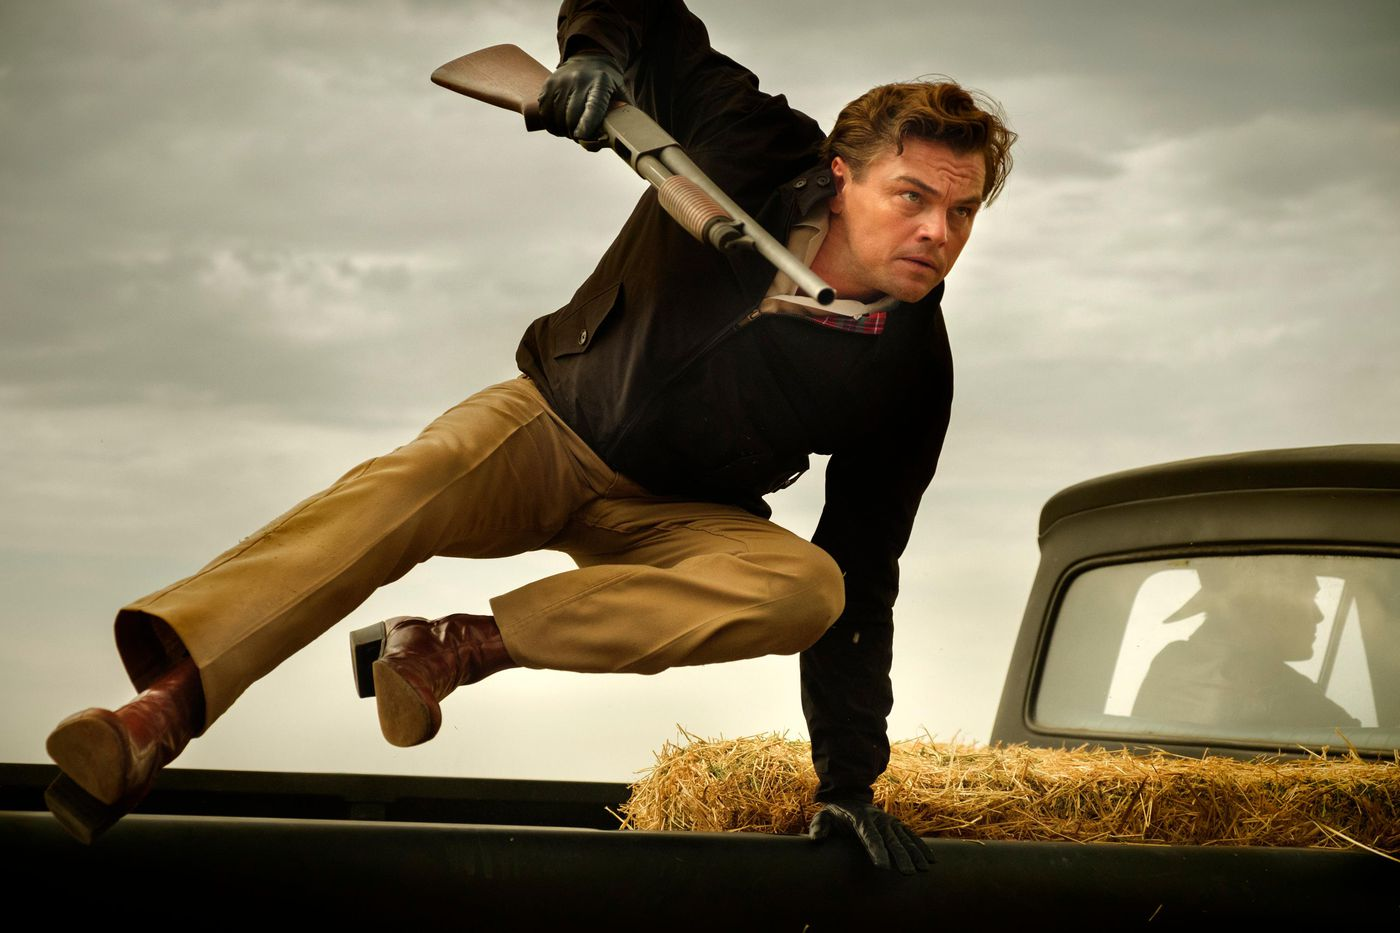Describe the setting and atmosphere of the image. The setting appears to be rural, indicated by the presence of hay on the hood of a vintage car. The cloudy sky adds an element of atmospheric tension, setting a dramatic scene. The overall atmosphere feels intense and action-packed, as the man, dressed in a black jacket, red shirt, and tan pants, leaps over the car with a shotgun, suggesting a high-stakes scenario. The earthy tones of his clothing and the surroundings enhance the feeling of being in an open, rugged environment. 